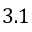Convert formula to latex. <formula><loc_0><loc_0><loc_500><loc_500>3 . 1</formula> 